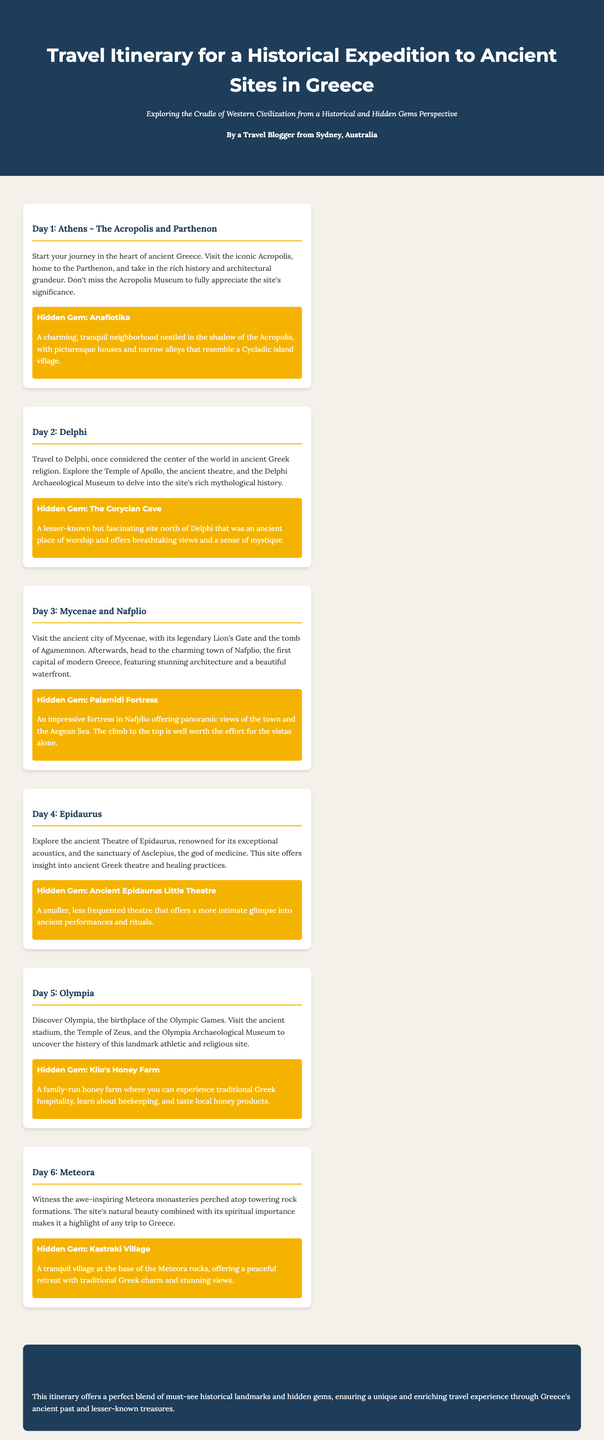What is the title of the travel itinerary? The title is the main heading of the document and introduces the subject matter.
Answer: Travel Itinerary for a Historical Expedition to Ancient Sites in Greece Who is the author of the itinerary? The author is mentioned in the document and reflects the personal touch of the travelogue.
Answer: A Travel Blogger from Sydney, Australia What is the hidden gem for Day 2? The hidden gems are highlighted within each day's section, offering recommendations beyond the main attractions.
Answer: The Corycian Cave How many days does the itinerary cover? The number of days is determined by counting each day's entry in the itinerary.
Answer: 6 Which ancient site is referred to as the birthplace of the Olympic Games? This site is explicitly mentioned in the activities listed in the document.
Answer: Olympia What type of experience does the itinerary aim to provide? The aim or theme of the itinerary is expressed in the subtitle of the document.
Answer: Unique and enriching travel experience What is the main focus of Day 5's activities? The main focus can be found by summarizing the activities listed for that day.
Answer: Olympia Which day includes a visit to the ancient Theatre of Epidaurus? This is detailed under the day's title and activities.
Answer: Day 4 